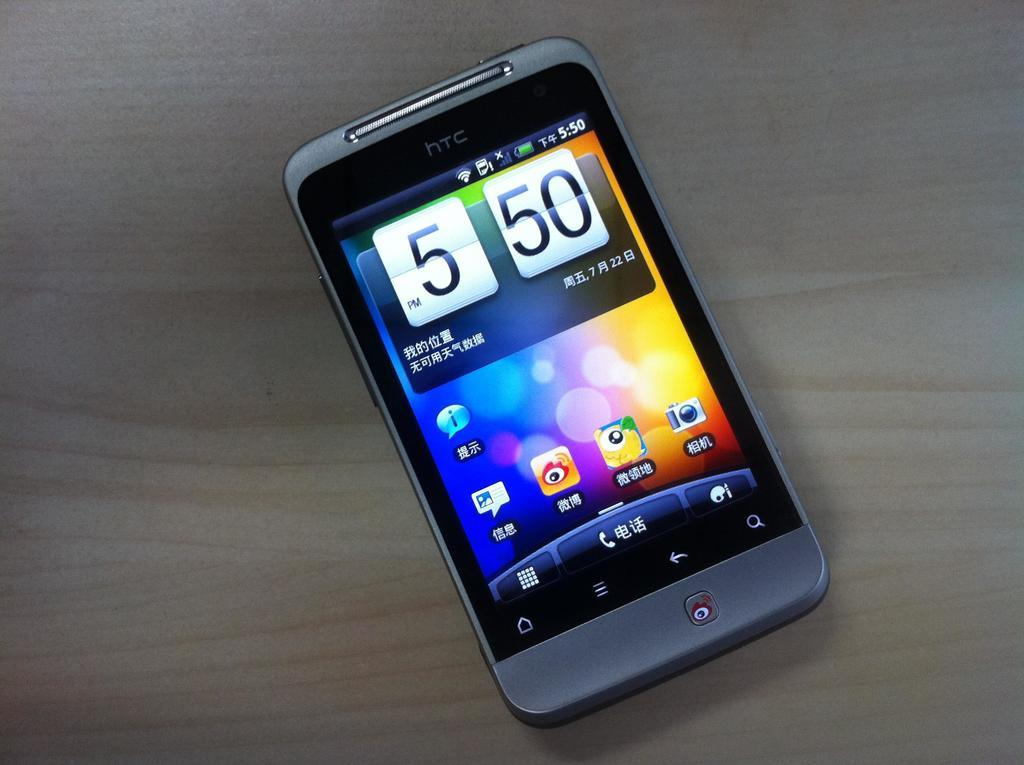<image>
Share a concise interpretation of the image provided. The time on this HTC phone says 5:50. 